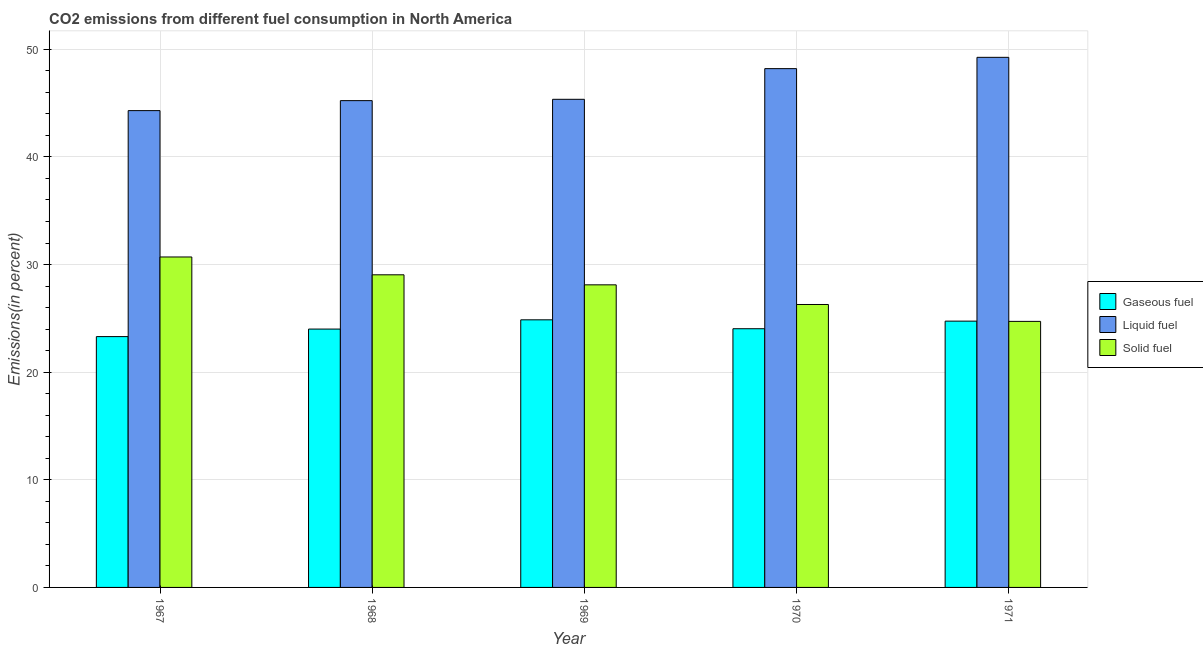How many different coloured bars are there?
Keep it short and to the point. 3. Are the number of bars per tick equal to the number of legend labels?
Ensure brevity in your answer.  Yes. Are the number of bars on each tick of the X-axis equal?
Keep it short and to the point. Yes. How many bars are there on the 3rd tick from the left?
Make the answer very short. 3. What is the label of the 3rd group of bars from the left?
Your answer should be very brief. 1969. What is the percentage of solid fuel emission in 1970?
Ensure brevity in your answer.  26.29. Across all years, what is the maximum percentage of gaseous fuel emission?
Your answer should be very brief. 24.87. Across all years, what is the minimum percentage of solid fuel emission?
Keep it short and to the point. 24.72. In which year was the percentage of liquid fuel emission maximum?
Give a very brief answer. 1971. In which year was the percentage of solid fuel emission minimum?
Keep it short and to the point. 1971. What is the total percentage of liquid fuel emission in the graph?
Offer a terse response. 232.35. What is the difference between the percentage of solid fuel emission in 1967 and that in 1968?
Offer a terse response. 1.66. What is the difference between the percentage of liquid fuel emission in 1969 and the percentage of solid fuel emission in 1970?
Your response must be concise. -2.85. What is the average percentage of solid fuel emission per year?
Keep it short and to the point. 27.78. In the year 1970, what is the difference between the percentage of solid fuel emission and percentage of liquid fuel emission?
Offer a very short reply. 0. What is the ratio of the percentage of liquid fuel emission in 1967 to that in 1968?
Ensure brevity in your answer.  0.98. What is the difference between the highest and the second highest percentage of liquid fuel emission?
Ensure brevity in your answer.  1.05. What is the difference between the highest and the lowest percentage of gaseous fuel emission?
Give a very brief answer. 1.56. Is the sum of the percentage of gaseous fuel emission in 1969 and 1970 greater than the maximum percentage of solid fuel emission across all years?
Your answer should be very brief. Yes. What does the 2nd bar from the left in 1967 represents?
Your answer should be compact. Liquid fuel. What does the 1st bar from the right in 1968 represents?
Offer a terse response. Solid fuel. Is it the case that in every year, the sum of the percentage of gaseous fuel emission and percentage of liquid fuel emission is greater than the percentage of solid fuel emission?
Keep it short and to the point. Yes. How many bars are there?
Your answer should be very brief. 15. Are all the bars in the graph horizontal?
Give a very brief answer. No. How many years are there in the graph?
Give a very brief answer. 5. Does the graph contain any zero values?
Keep it short and to the point. No. Does the graph contain grids?
Ensure brevity in your answer.  Yes. Where does the legend appear in the graph?
Make the answer very short. Center right. How many legend labels are there?
Ensure brevity in your answer.  3. What is the title of the graph?
Give a very brief answer. CO2 emissions from different fuel consumption in North America. What is the label or title of the X-axis?
Offer a very short reply. Year. What is the label or title of the Y-axis?
Give a very brief answer. Emissions(in percent). What is the Emissions(in percent) of Gaseous fuel in 1967?
Provide a short and direct response. 23.31. What is the Emissions(in percent) of Liquid fuel in 1967?
Provide a short and direct response. 44.3. What is the Emissions(in percent) of Solid fuel in 1967?
Provide a succinct answer. 30.7. What is the Emissions(in percent) of Gaseous fuel in 1968?
Offer a terse response. 24.01. What is the Emissions(in percent) in Liquid fuel in 1968?
Your answer should be compact. 45.23. What is the Emissions(in percent) of Solid fuel in 1968?
Offer a terse response. 29.05. What is the Emissions(in percent) of Gaseous fuel in 1969?
Offer a very short reply. 24.87. What is the Emissions(in percent) of Liquid fuel in 1969?
Offer a very short reply. 45.36. What is the Emissions(in percent) of Solid fuel in 1969?
Offer a terse response. 28.12. What is the Emissions(in percent) in Gaseous fuel in 1970?
Keep it short and to the point. 24.04. What is the Emissions(in percent) in Liquid fuel in 1970?
Make the answer very short. 48.21. What is the Emissions(in percent) in Solid fuel in 1970?
Ensure brevity in your answer.  26.29. What is the Emissions(in percent) of Gaseous fuel in 1971?
Provide a succinct answer. 24.74. What is the Emissions(in percent) of Liquid fuel in 1971?
Keep it short and to the point. 49.26. What is the Emissions(in percent) in Solid fuel in 1971?
Provide a succinct answer. 24.72. Across all years, what is the maximum Emissions(in percent) in Gaseous fuel?
Your response must be concise. 24.87. Across all years, what is the maximum Emissions(in percent) in Liquid fuel?
Your response must be concise. 49.26. Across all years, what is the maximum Emissions(in percent) in Solid fuel?
Provide a succinct answer. 30.7. Across all years, what is the minimum Emissions(in percent) of Gaseous fuel?
Offer a very short reply. 23.31. Across all years, what is the minimum Emissions(in percent) of Liquid fuel?
Your response must be concise. 44.3. Across all years, what is the minimum Emissions(in percent) of Solid fuel?
Provide a succinct answer. 24.72. What is the total Emissions(in percent) in Gaseous fuel in the graph?
Make the answer very short. 120.96. What is the total Emissions(in percent) in Liquid fuel in the graph?
Keep it short and to the point. 232.35. What is the total Emissions(in percent) in Solid fuel in the graph?
Ensure brevity in your answer.  138.88. What is the difference between the Emissions(in percent) in Gaseous fuel in 1967 and that in 1968?
Give a very brief answer. -0.7. What is the difference between the Emissions(in percent) of Liquid fuel in 1967 and that in 1968?
Offer a very short reply. -0.93. What is the difference between the Emissions(in percent) of Solid fuel in 1967 and that in 1968?
Provide a short and direct response. 1.66. What is the difference between the Emissions(in percent) of Gaseous fuel in 1967 and that in 1969?
Offer a terse response. -1.56. What is the difference between the Emissions(in percent) of Liquid fuel in 1967 and that in 1969?
Keep it short and to the point. -1.05. What is the difference between the Emissions(in percent) in Solid fuel in 1967 and that in 1969?
Provide a short and direct response. 2.59. What is the difference between the Emissions(in percent) of Gaseous fuel in 1967 and that in 1970?
Offer a very short reply. -0.73. What is the difference between the Emissions(in percent) in Liquid fuel in 1967 and that in 1970?
Give a very brief answer. -3.9. What is the difference between the Emissions(in percent) of Solid fuel in 1967 and that in 1970?
Offer a very short reply. 4.41. What is the difference between the Emissions(in percent) of Gaseous fuel in 1967 and that in 1971?
Provide a succinct answer. -1.44. What is the difference between the Emissions(in percent) of Liquid fuel in 1967 and that in 1971?
Make the answer very short. -4.95. What is the difference between the Emissions(in percent) in Solid fuel in 1967 and that in 1971?
Provide a short and direct response. 5.98. What is the difference between the Emissions(in percent) in Gaseous fuel in 1968 and that in 1969?
Your answer should be very brief. -0.86. What is the difference between the Emissions(in percent) in Liquid fuel in 1968 and that in 1969?
Your response must be concise. -0.12. What is the difference between the Emissions(in percent) of Solid fuel in 1968 and that in 1969?
Offer a very short reply. 0.93. What is the difference between the Emissions(in percent) of Gaseous fuel in 1968 and that in 1970?
Ensure brevity in your answer.  -0.03. What is the difference between the Emissions(in percent) of Liquid fuel in 1968 and that in 1970?
Offer a terse response. -2.97. What is the difference between the Emissions(in percent) of Solid fuel in 1968 and that in 1970?
Your response must be concise. 2.76. What is the difference between the Emissions(in percent) in Gaseous fuel in 1968 and that in 1971?
Offer a terse response. -0.74. What is the difference between the Emissions(in percent) of Liquid fuel in 1968 and that in 1971?
Your response must be concise. -4.02. What is the difference between the Emissions(in percent) of Solid fuel in 1968 and that in 1971?
Ensure brevity in your answer.  4.33. What is the difference between the Emissions(in percent) of Gaseous fuel in 1969 and that in 1970?
Your answer should be very brief. 0.83. What is the difference between the Emissions(in percent) in Liquid fuel in 1969 and that in 1970?
Give a very brief answer. -2.85. What is the difference between the Emissions(in percent) of Solid fuel in 1969 and that in 1970?
Keep it short and to the point. 1.83. What is the difference between the Emissions(in percent) of Gaseous fuel in 1969 and that in 1971?
Make the answer very short. 0.12. What is the difference between the Emissions(in percent) in Liquid fuel in 1969 and that in 1971?
Keep it short and to the point. -3.9. What is the difference between the Emissions(in percent) in Solid fuel in 1969 and that in 1971?
Your response must be concise. 3.4. What is the difference between the Emissions(in percent) in Gaseous fuel in 1970 and that in 1971?
Make the answer very short. -0.71. What is the difference between the Emissions(in percent) of Liquid fuel in 1970 and that in 1971?
Provide a succinct answer. -1.05. What is the difference between the Emissions(in percent) in Solid fuel in 1970 and that in 1971?
Give a very brief answer. 1.57. What is the difference between the Emissions(in percent) in Gaseous fuel in 1967 and the Emissions(in percent) in Liquid fuel in 1968?
Ensure brevity in your answer.  -21.92. What is the difference between the Emissions(in percent) of Gaseous fuel in 1967 and the Emissions(in percent) of Solid fuel in 1968?
Your answer should be compact. -5.74. What is the difference between the Emissions(in percent) of Liquid fuel in 1967 and the Emissions(in percent) of Solid fuel in 1968?
Give a very brief answer. 15.26. What is the difference between the Emissions(in percent) in Gaseous fuel in 1967 and the Emissions(in percent) in Liquid fuel in 1969?
Offer a very short reply. -22.05. What is the difference between the Emissions(in percent) in Gaseous fuel in 1967 and the Emissions(in percent) in Solid fuel in 1969?
Your answer should be compact. -4.81. What is the difference between the Emissions(in percent) in Liquid fuel in 1967 and the Emissions(in percent) in Solid fuel in 1969?
Make the answer very short. 16.19. What is the difference between the Emissions(in percent) in Gaseous fuel in 1967 and the Emissions(in percent) in Liquid fuel in 1970?
Give a very brief answer. -24.9. What is the difference between the Emissions(in percent) in Gaseous fuel in 1967 and the Emissions(in percent) in Solid fuel in 1970?
Keep it short and to the point. -2.98. What is the difference between the Emissions(in percent) in Liquid fuel in 1967 and the Emissions(in percent) in Solid fuel in 1970?
Your answer should be compact. 18.01. What is the difference between the Emissions(in percent) in Gaseous fuel in 1967 and the Emissions(in percent) in Liquid fuel in 1971?
Ensure brevity in your answer.  -25.95. What is the difference between the Emissions(in percent) in Gaseous fuel in 1967 and the Emissions(in percent) in Solid fuel in 1971?
Provide a succinct answer. -1.41. What is the difference between the Emissions(in percent) in Liquid fuel in 1967 and the Emissions(in percent) in Solid fuel in 1971?
Your answer should be very brief. 19.58. What is the difference between the Emissions(in percent) of Gaseous fuel in 1968 and the Emissions(in percent) of Liquid fuel in 1969?
Keep it short and to the point. -21.35. What is the difference between the Emissions(in percent) of Gaseous fuel in 1968 and the Emissions(in percent) of Solid fuel in 1969?
Your answer should be compact. -4.11. What is the difference between the Emissions(in percent) in Liquid fuel in 1968 and the Emissions(in percent) in Solid fuel in 1969?
Offer a terse response. 17.11. What is the difference between the Emissions(in percent) of Gaseous fuel in 1968 and the Emissions(in percent) of Liquid fuel in 1970?
Provide a short and direct response. -24.2. What is the difference between the Emissions(in percent) of Gaseous fuel in 1968 and the Emissions(in percent) of Solid fuel in 1970?
Ensure brevity in your answer.  -2.28. What is the difference between the Emissions(in percent) in Liquid fuel in 1968 and the Emissions(in percent) in Solid fuel in 1970?
Ensure brevity in your answer.  18.94. What is the difference between the Emissions(in percent) in Gaseous fuel in 1968 and the Emissions(in percent) in Liquid fuel in 1971?
Your answer should be very brief. -25.25. What is the difference between the Emissions(in percent) in Gaseous fuel in 1968 and the Emissions(in percent) in Solid fuel in 1971?
Offer a very short reply. -0.71. What is the difference between the Emissions(in percent) of Liquid fuel in 1968 and the Emissions(in percent) of Solid fuel in 1971?
Your answer should be very brief. 20.51. What is the difference between the Emissions(in percent) in Gaseous fuel in 1969 and the Emissions(in percent) in Liquid fuel in 1970?
Your answer should be compact. -23.34. What is the difference between the Emissions(in percent) of Gaseous fuel in 1969 and the Emissions(in percent) of Solid fuel in 1970?
Your response must be concise. -1.42. What is the difference between the Emissions(in percent) of Liquid fuel in 1969 and the Emissions(in percent) of Solid fuel in 1970?
Your answer should be compact. 19.07. What is the difference between the Emissions(in percent) in Gaseous fuel in 1969 and the Emissions(in percent) in Liquid fuel in 1971?
Provide a succinct answer. -24.39. What is the difference between the Emissions(in percent) in Gaseous fuel in 1969 and the Emissions(in percent) in Solid fuel in 1971?
Provide a succinct answer. 0.15. What is the difference between the Emissions(in percent) in Liquid fuel in 1969 and the Emissions(in percent) in Solid fuel in 1971?
Make the answer very short. 20.64. What is the difference between the Emissions(in percent) of Gaseous fuel in 1970 and the Emissions(in percent) of Liquid fuel in 1971?
Provide a short and direct response. -25.22. What is the difference between the Emissions(in percent) of Gaseous fuel in 1970 and the Emissions(in percent) of Solid fuel in 1971?
Make the answer very short. -0.68. What is the difference between the Emissions(in percent) in Liquid fuel in 1970 and the Emissions(in percent) in Solid fuel in 1971?
Make the answer very short. 23.49. What is the average Emissions(in percent) of Gaseous fuel per year?
Offer a very short reply. 24.19. What is the average Emissions(in percent) in Liquid fuel per year?
Offer a terse response. 46.47. What is the average Emissions(in percent) of Solid fuel per year?
Your answer should be very brief. 27.78. In the year 1967, what is the difference between the Emissions(in percent) in Gaseous fuel and Emissions(in percent) in Liquid fuel?
Offer a very short reply. -21. In the year 1967, what is the difference between the Emissions(in percent) of Gaseous fuel and Emissions(in percent) of Solid fuel?
Give a very brief answer. -7.4. In the year 1967, what is the difference between the Emissions(in percent) of Liquid fuel and Emissions(in percent) of Solid fuel?
Your answer should be compact. 13.6. In the year 1968, what is the difference between the Emissions(in percent) of Gaseous fuel and Emissions(in percent) of Liquid fuel?
Offer a terse response. -21.23. In the year 1968, what is the difference between the Emissions(in percent) of Gaseous fuel and Emissions(in percent) of Solid fuel?
Offer a terse response. -5.04. In the year 1968, what is the difference between the Emissions(in percent) of Liquid fuel and Emissions(in percent) of Solid fuel?
Your answer should be compact. 16.18. In the year 1969, what is the difference between the Emissions(in percent) in Gaseous fuel and Emissions(in percent) in Liquid fuel?
Your response must be concise. -20.49. In the year 1969, what is the difference between the Emissions(in percent) of Gaseous fuel and Emissions(in percent) of Solid fuel?
Make the answer very short. -3.25. In the year 1969, what is the difference between the Emissions(in percent) of Liquid fuel and Emissions(in percent) of Solid fuel?
Your response must be concise. 17.24. In the year 1970, what is the difference between the Emissions(in percent) of Gaseous fuel and Emissions(in percent) of Liquid fuel?
Your answer should be compact. -24.17. In the year 1970, what is the difference between the Emissions(in percent) in Gaseous fuel and Emissions(in percent) in Solid fuel?
Ensure brevity in your answer.  -2.25. In the year 1970, what is the difference between the Emissions(in percent) of Liquid fuel and Emissions(in percent) of Solid fuel?
Provide a succinct answer. 21.92. In the year 1971, what is the difference between the Emissions(in percent) of Gaseous fuel and Emissions(in percent) of Liquid fuel?
Ensure brevity in your answer.  -24.51. In the year 1971, what is the difference between the Emissions(in percent) of Gaseous fuel and Emissions(in percent) of Solid fuel?
Provide a short and direct response. 0.02. In the year 1971, what is the difference between the Emissions(in percent) of Liquid fuel and Emissions(in percent) of Solid fuel?
Provide a succinct answer. 24.54. What is the ratio of the Emissions(in percent) in Gaseous fuel in 1967 to that in 1968?
Make the answer very short. 0.97. What is the ratio of the Emissions(in percent) in Liquid fuel in 1967 to that in 1968?
Your answer should be very brief. 0.98. What is the ratio of the Emissions(in percent) of Solid fuel in 1967 to that in 1968?
Your answer should be compact. 1.06. What is the ratio of the Emissions(in percent) in Gaseous fuel in 1967 to that in 1969?
Make the answer very short. 0.94. What is the ratio of the Emissions(in percent) in Liquid fuel in 1967 to that in 1969?
Your response must be concise. 0.98. What is the ratio of the Emissions(in percent) of Solid fuel in 1967 to that in 1969?
Your answer should be very brief. 1.09. What is the ratio of the Emissions(in percent) of Gaseous fuel in 1967 to that in 1970?
Ensure brevity in your answer.  0.97. What is the ratio of the Emissions(in percent) of Liquid fuel in 1967 to that in 1970?
Make the answer very short. 0.92. What is the ratio of the Emissions(in percent) of Solid fuel in 1967 to that in 1970?
Offer a very short reply. 1.17. What is the ratio of the Emissions(in percent) of Gaseous fuel in 1967 to that in 1971?
Give a very brief answer. 0.94. What is the ratio of the Emissions(in percent) in Liquid fuel in 1967 to that in 1971?
Offer a very short reply. 0.9. What is the ratio of the Emissions(in percent) in Solid fuel in 1967 to that in 1971?
Ensure brevity in your answer.  1.24. What is the ratio of the Emissions(in percent) in Gaseous fuel in 1968 to that in 1969?
Offer a terse response. 0.97. What is the ratio of the Emissions(in percent) in Liquid fuel in 1968 to that in 1969?
Your response must be concise. 1. What is the ratio of the Emissions(in percent) of Solid fuel in 1968 to that in 1969?
Offer a terse response. 1.03. What is the ratio of the Emissions(in percent) of Gaseous fuel in 1968 to that in 1970?
Your answer should be compact. 1. What is the ratio of the Emissions(in percent) of Liquid fuel in 1968 to that in 1970?
Ensure brevity in your answer.  0.94. What is the ratio of the Emissions(in percent) of Solid fuel in 1968 to that in 1970?
Keep it short and to the point. 1.1. What is the ratio of the Emissions(in percent) of Gaseous fuel in 1968 to that in 1971?
Provide a short and direct response. 0.97. What is the ratio of the Emissions(in percent) in Liquid fuel in 1968 to that in 1971?
Provide a succinct answer. 0.92. What is the ratio of the Emissions(in percent) of Solid fuel in 1968 to that in 1971?
Offer a very short reply. 1.18. What is the ratio of the Emissions(in percent) of Gaseous fuel in 1969 to that in 1970?
Offer a very short reply. 1.03. What is the ratio of the Emissions(in percent) of Liquid fuel in 1969 to that in 1970?
Your answer should be very brief. 0.94. What is the ratio of the Emissions(in percent) in Solid fuel in 1969 to that in 1970?
Keep it short and to the point. 1.07. What is the ratio of the Emissions(in percent) in Gaseous fuel in 1969 to that in 1971?
Keep it short and to the point. 1. What is the ratio of the Emissions(in percent) in Liquid fuel in 1969 to that in 1971?
Your response must be concise. 0.92. What is the ratio of the Emissions(in percent) in Solid fuel in 1969 to that in 1971?
Your answer should be very brief. 1.14. What is the ratio of the Emissions(in percent) of Gaseous fuel in 1970 to that in 1971?
Your response must be concise. 0.97. What is the ratio of the Emissions(in percent) in Liquid fuel in 1970 to that in 1971?
Give a very brief answer. 0.98. What is the ratio of the Emissions(in percent) in Solid fuel in 1970 to that in 1971?
Ensure brevity in your answer.  1.06. What is the difference between the highest and the second highest Emissions(in percent) of Gaseous fuel?
Your response must be concise. 0.12. What is the difference between the highest and the second highest Emissions(in percent) of Liquid fuel?
Give a very brief answer. 1.05. What is the difference between the highest and the second highest Emissions(in percent) in Solid fuel?
Offer a terse response. 1.66. What is the difference between the highest and the lowest Emissions(in percent) in Gaseous fuel?
Offer a terse response. 1.56. What is the difference between the highest and the lowest Emissions(in percent) in Liquid fuel?
Provide a short and direct response. 4.95. What is the difference between the highest and the lowest Emissions(in percent) in Solid fuel?
Your answer should be compact. 5.98. 